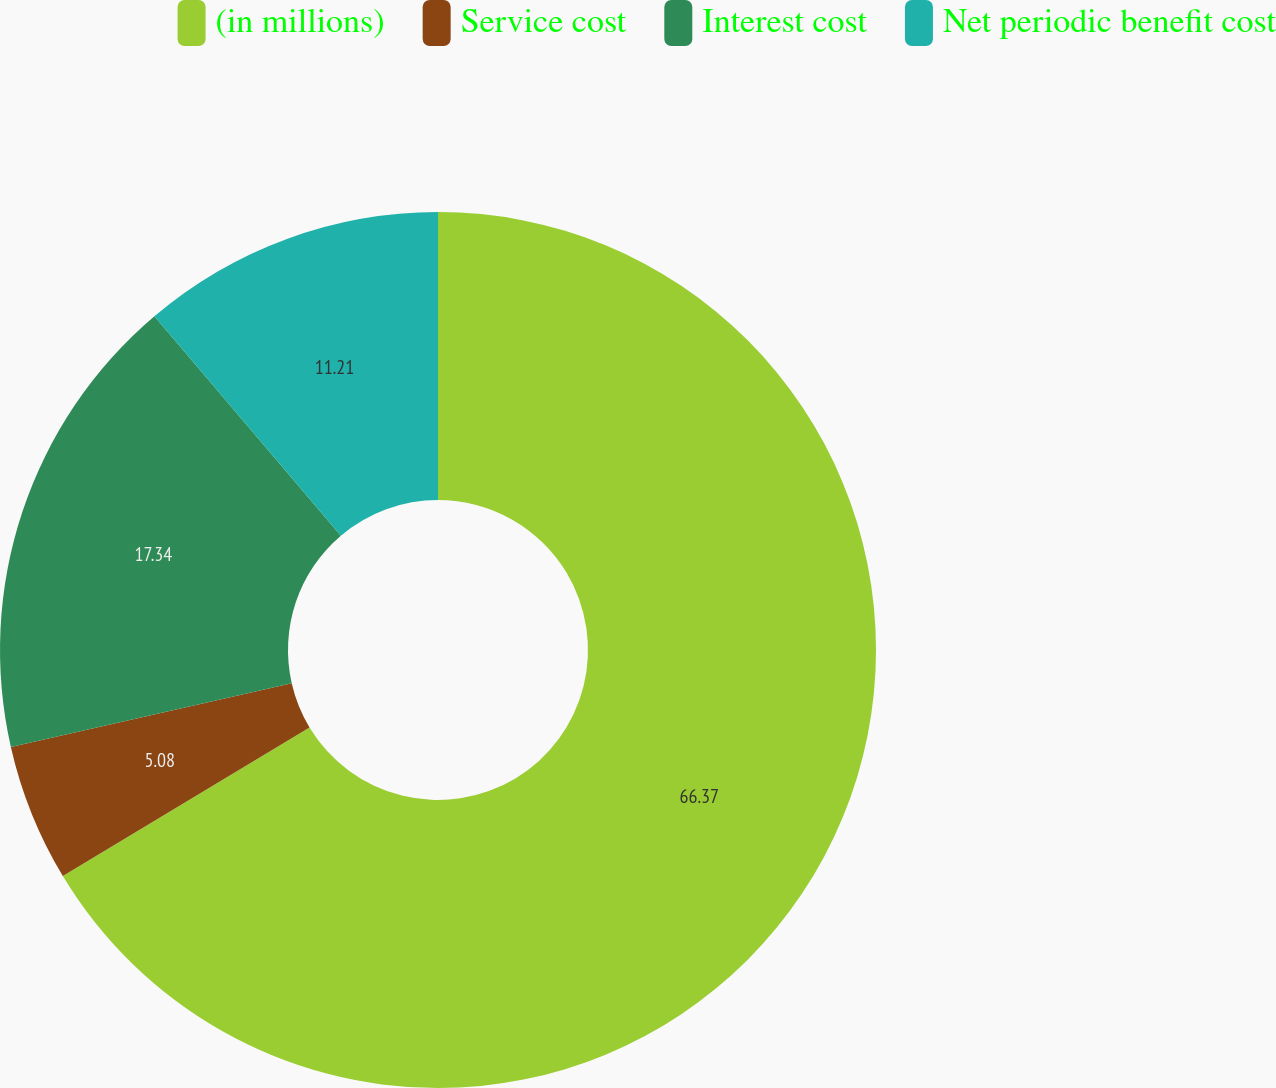<chart> <loc_0><loc_0><loc_500><loc_500><pie_chart><fcel>(in millions)<fcel>Service cost<fcel>Interest cost<fcel>Net periodic benefit cost<nl><fcel>66.37%<fcel>5.08%<fcel>17.34%<fcel>11.21%<nl></chart> 